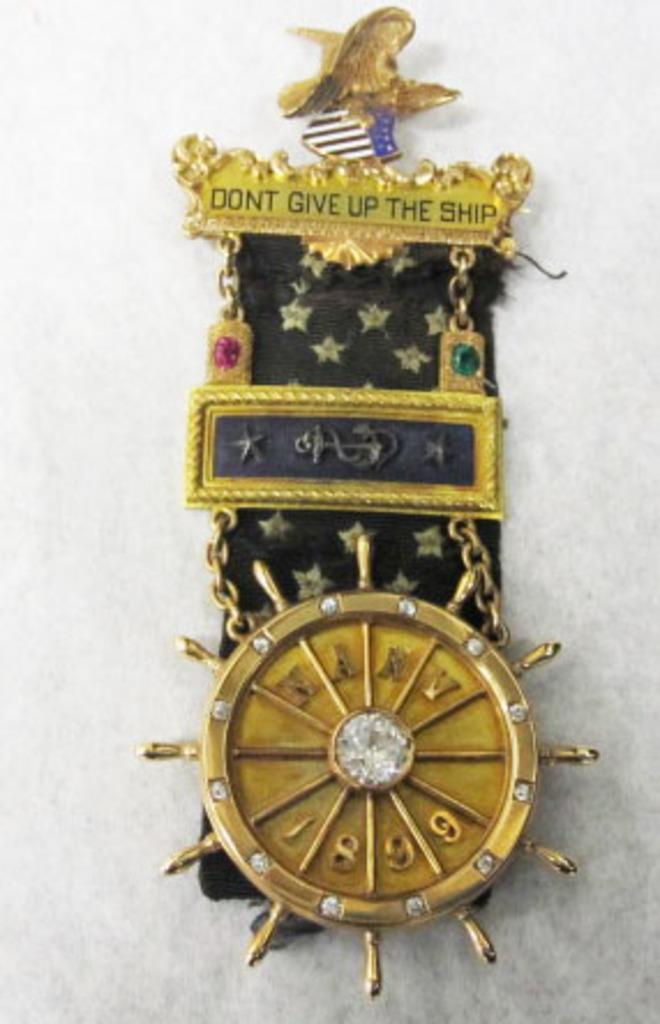<image>
Render a clear and concise summary of the photo. The pin says don't give up the ship across the top. 